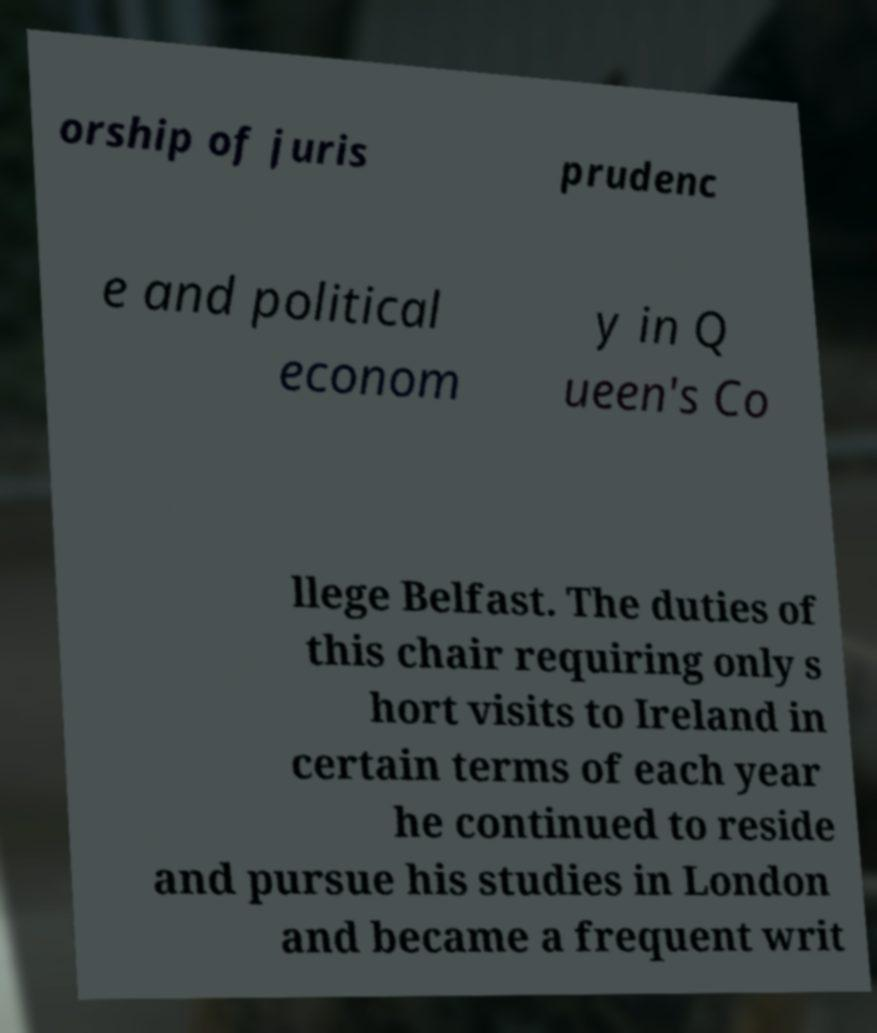Could you extract and type out the text from this image? orship of juris prudenc e and political econom y in Q ueen's Co llege Belfast. The duties of this chair requiring only s hort visits to Ireland in certain terms of each year he continued to reside and pursue his studies in London and became a frequent writ 